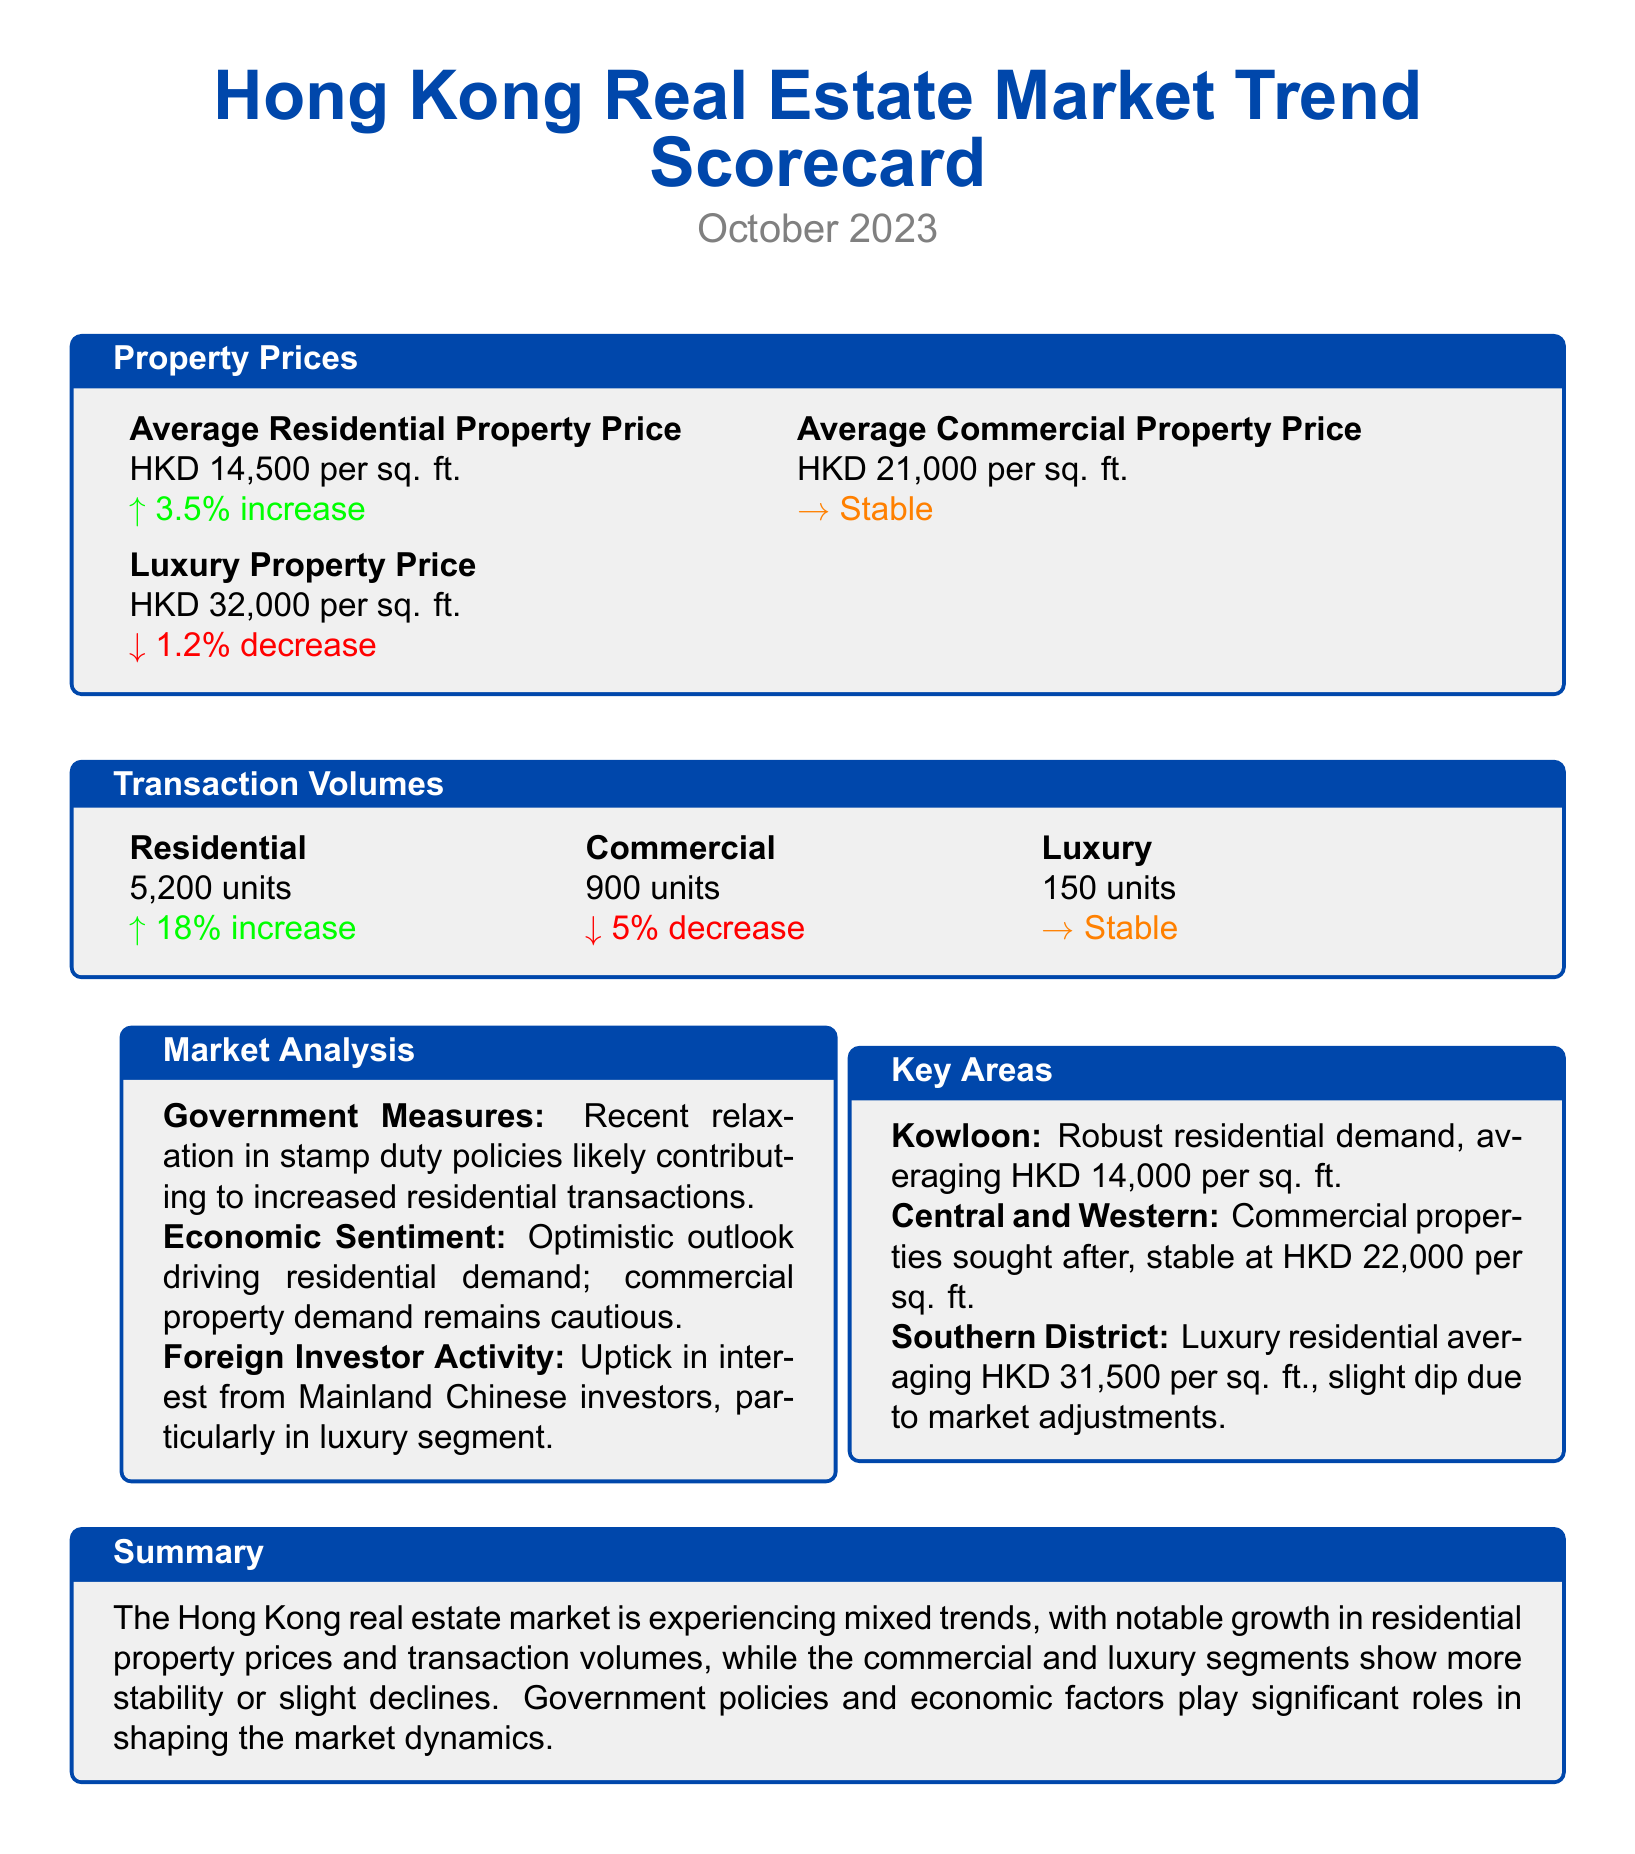what is the average residential property price? The average residential property price is specified in the document, which is HKD 14,500 per sq. ft.
Answer: HKD 14,500 per sq. ft what is the percentage change in average residential property price? The document states that the average residential property price has increased by 3.5%.
Answer: 3.5% increase how many residential units were transacted? The total number of residential units transacted is provided in the transaction volumes section as 5,200 units.
Answer: 5,200 units what is the average price for luxury properties? The document lists the average price for luxury properties as HKD 32,000 per sq. ft.
Answer: HKD 32,000 per sq. ft what government measures impacted residential transactions? The document mentions the relaxation in stamp duty policies as a measure that likely contributed to increased residential transactions.
Answer: Relaxation in stamp duty policies how much did commercial property transactions decline? The document indicates that commercial property transactions decreased by 5%.
Answer: 5% decrease which area has robust residential demand? The document highlights Kowloon as an area with robust residential demand.
Answer: Kowloon what is the average luxury residential price in the Southern District? The average luxury residential price in the Southern District is given as HKD 31,500 per sq. ft.
Answer: HKD 31,500 per sq. ft what is the summary of market trends? The document provides a summary stating that the market is experiencing mixed trends with notable growth in residential properties.
Answer: Mixed trends with notable growth in residential properties 